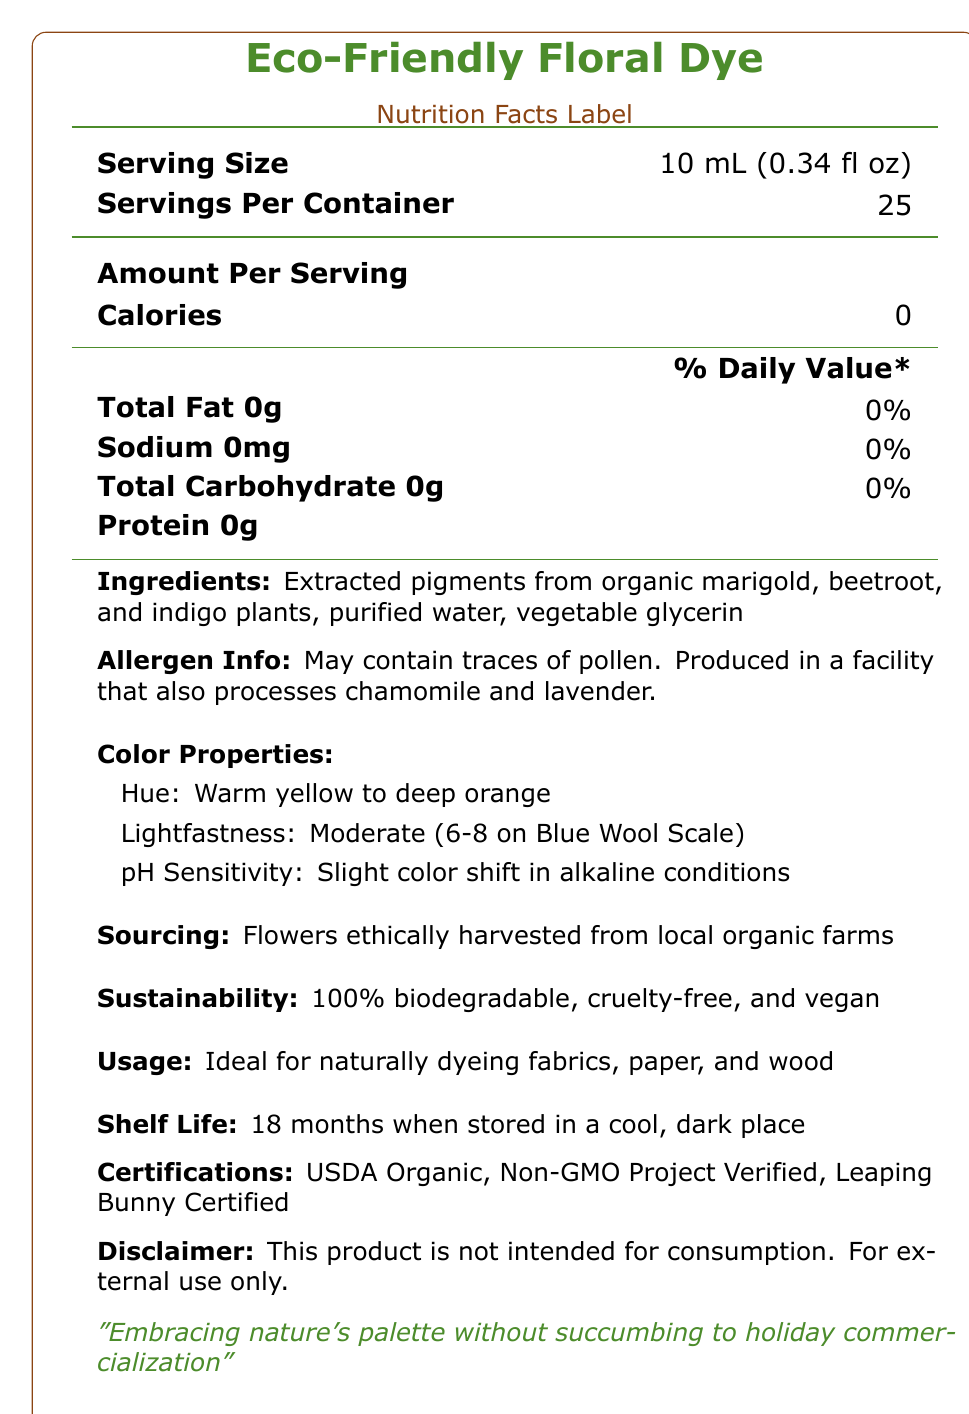what is the serving size for the Eco-Friendly Floral Dye? The document specifies that the serving size is 10 mL (0.34 fl oz).
Answer: 10 mL (0.34 fl oz) how many servings are there per container? The document states that there are 25 servings per container.
Answer: 25 how many calories are there per serving? According to the nutrition facts, there are 0 calories per serving.
Answer: 0 which ingredients are used in the Eco-Friendly Floral Dye? The ingredients listed include extracted pigments from organic marigold, beetroot, and indigo plants, purified water, and vegetable glycerin.
Answer: Extracted pigments from organic marigold, beetroot, and indigo plants, purified water, vegetable glycerin what is the allergen information for the product? The allergen information provided mentions that the product may contain traces of pollen and is produced in a facility that also processes chamomile and lavender.
Answer: May contain traces of pollen. Produced in a facility that also processes chamomile and lavender. what is the lightfastness rating of the dye? The document describes the lightfastness as moderate, specifically 6-8 on the Blue Wool Scale.
Answer: Moderate (6-8 on Blue Wool Scale) for which materials is this dye ideal? The usage section mentions that the dye is ideal for naturally dyeing fabrics, paper, and wood.
Answer: Fabrics, paper, and wood how many months is the shelf life of this dye? It is stated that the shelf life is 18 months when stored in a cool, dark place.
Answer: 18 months what certifications does this product have? A. USDA Organic B. Fair Trade C. Leaping Bunny Certified D. Non-GMO Project Verified The product is certified as USDA Organic, Non-GMO Project Verified, and Leaping Bunny Certified. Fair Trade is not listed as a certification.
Answer: A, C, and D what emotion is associated with the color yellow according to the color psychology? A. Warmth B. Optimism C. Serenity D. Passion The color psychology section indicates that yellow promotes creativity and optimism, so the correct answer is optimism.
Answer: B is the product intended for consumption? The disclaimer clearly states that the product is not intended for consumption and is for external use only.
Answer: No can the production facility be processing peanuts? The document mentions that the facility processes chamomile and lavender, but it does not state anything about peanuts.
Answer: I don't know what are the seasonal availability options for this product? The document details the seasonal availability of various flowers used for the dye, segmented by seasons.
Answer: Spring: Dandelion, Violet; Summer: Marigold, Sunflower; Autumn: Goldenrod, Sumac; Winter: Beetroot, Indigo does the product promote biodiversity in local ecosystems? The document mentions under environmental benefits that the product reduces chemical runoff and promotes biodiversity in local ecosystems.
Answer: Yes summarize the main idea of the document. The document aims to provide a comprehensive overview of the Eco-Friendly Floral Dye, focusing on its natural ingredients, eco-friendly credentials, and appropriate uses, as well as its various sustainable and ethical certifications and benefits.
Answer: The document provides detailed information about the Eco-Friendly Floral Dye, a plant-based dye that is sustainable, biodegradable, vegan, and ethically sourced. It outlines the nutritional facts, ingredients, allergen information, color properties, certifications, sustainability aspects, usage, shelf life, seasonal availability, and environmental benefits. It also includes a brand statement emphasizing the natural, non-commercial nature of the product. 